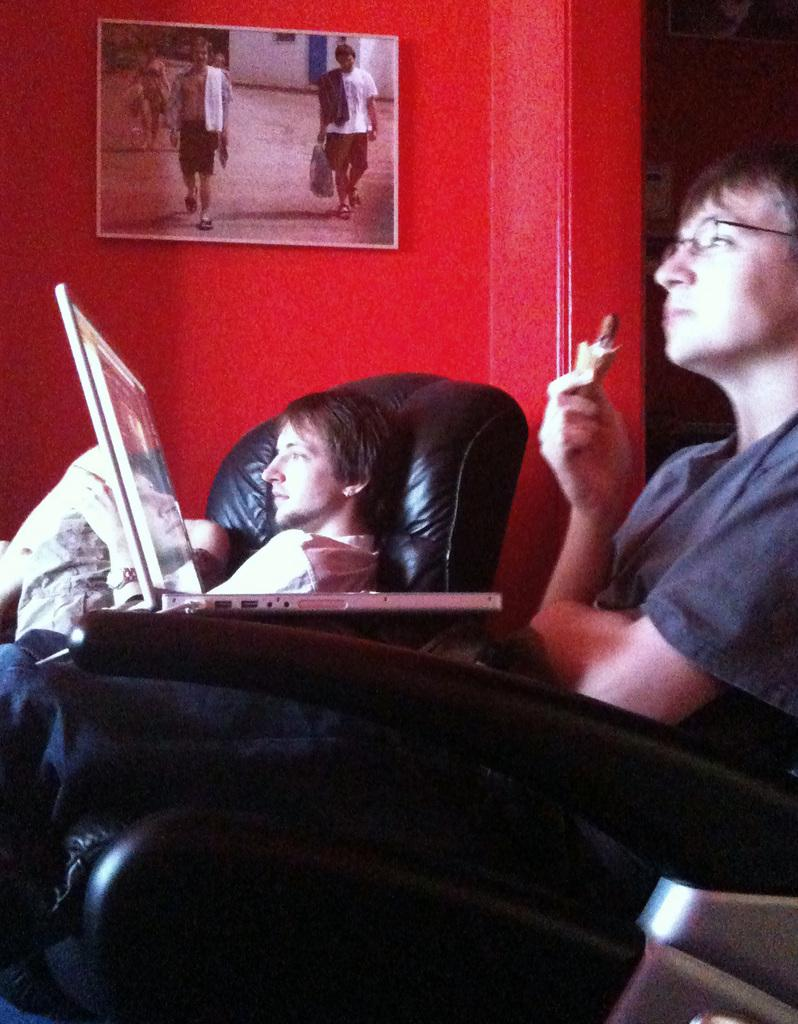What is the man on the recliner doing in the image? There is a man standing on a recliner in the image. What is the other man in the image doing? There is a man with a laptop in front of the recliner, and he has the laptop on his lap. What can be seen in the background of the image? There is a photograph in the background of the image. How many ants can be seen crawling on the man with the laptop in the image? There are no ants visible in the image. What level of respect is shown by the man standing on the recliner in the image? The image does not convey any information about the level of respect shown by the man standing on the recliner. 